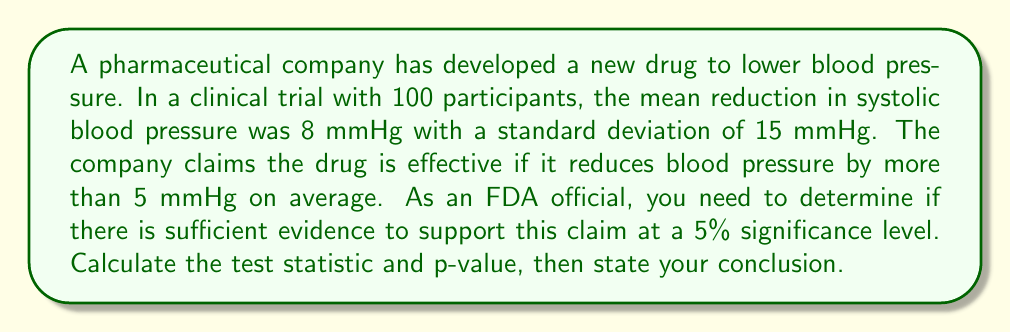Show me your answer to this math problem. To determine the statistical significance, we'll use a one-tailed hypothesis test:

1. Set up the hypotheses:
   $H_0: \mu \le 5$ (null hypothesis)
   $H_a: \mu > 5$ (alternative hypothesis)

2. Choose the significance level: $\alpha = 0.05$

3. Calculate the test statistic (z-score):
   $$z = \frac{\bar{x} - \mu_0}{\sigma / \sqrt{n}}$$
   where $\bar{x}$ is the sample mean (8 mmHg), $\mu_0$ is the hypothesized population mean (5 mmHg), $\sigma$ is the standard deviation (15 mmHg), and $n$ is the sample size (100).

   $$z = \frac{8 - 5}{15 / \sqrt{100}} = \frac{3}{15 / 10} = \frac{3}{1.5} = 2$$

4. Calculate the p-value:
   The p-value is the probability of obtaining a test statistic as extreme as or more extreme than the observed value, assuming the null hypothesis is true.

   For a one-tailed test, p-value = $P(Z > z)$ = $1 - P(Z \le z)$
   Using a standard normal distribution table or calculator:
   p-value = $1 - P(Z \le 2) = 1 - 0.9772 = 0.0228$

5. Compare the p-value to the significance level:
   Since $0.0228 < 0.05$, we reject the null hypothesis.

6. Conclusion:
   There is sufficient evidence to conclude that the drug is effective in reducing blood pressure by more than 5 mmHg on average, with a p-value of 0.0228.
Answer: Reject $H_0$; p-value = 0.0228 